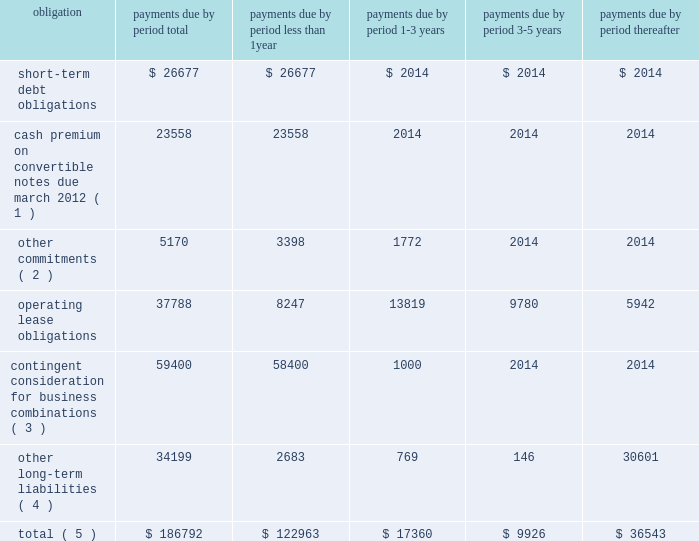Contractual cash flows following is a summary of our contractual payment obligations related to our consolidated debt , contingent consideration , operating leases , other commitments and long-term liabilities at september 30 , 2011 ( see notes 9 and 13 to the consolidated financial statements contained this annual report ) , ( in thousands ) : .
( 1 ) cash premiums related to the 201cif converted 201d value of the 2007 convertible notes that exceed aggregate principal balance using the closing stock price of $ 17.96 on september 30 , 2011 .
The actual amount of the cash premium will be calculated based on the 20 day average stock price prior to maturity .
A $ 1.00 change in our stock price would change the 201cif converted 201d value of the cash premium of the total aggregate principle amount of the remaining convertible notes by approximately $ 2.8 million .
( 2 ) other commitments consist of contractual license and royalty payments , and other purchase obligations .
( 3 ) contingent consideration related to business combinations is recorded at fair value and actual results could differ .
( 4 ) other long-term liabilities includes our gross unrecognized tax benefits , as well as executive deferred compensation which are both classified as beyond five years due to the uncertain nature of the commitment .
( 5 ) amounts do not include potential cash payments for the pending acquisition of aati .
Critical accounting estimates the discussion and analysis of our financial condition and results of operations are based upon our consolidated financial statements , which have been prepared in accordance with gaap .
The preparation of these financial statements requires us to make estimates and judgments that affect the reported amounts of assets , liabilities , revenues and expenses , and related disclosure of contingent assets and liabilities .
The sec has defined critical accounting policies as those that are both most important to the portrayal of our financial condition and results and which require our most difficult , complex or subjective judgments or estimates .
Based on this definition , we believe our critical accounting policies include the policies of revenue recognition , allowance for doubtful accounts , inventory valuation , business combinations , valuation of long-lived assets , share-based compensation , income taxes , goodwill and intangibles , and loss contingencies .
On an ongoing basis , we evaluate the judgments and estimates underlying all of our accounting policies .
These estimates and the underlying assumptions affect the amounts of assets and liabilities reported , disclosures , and reported amounts of revenues and expenses .
These estimates and assumptions are based on our best judgments .
We evaluate our estimates and assumptions using historical experience and other factors , including the current economic environment , which we believe to be reasonable under the circumstances .
We adjust such estimates and assumptions when facts and circumstances dictate .
As future events and their effects cannot be determined with precision , actual results could differ significantly from these estimates .
Page 80 skyworks / annual report 2011 .
What portion of total liabilities is due in less than 1 year? 
Computations: (122963 / 186792)
Answer: 0.65829. 